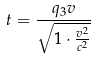<formula> <loc_0><loc_0><loc_500><loc_500>t = \frac { q _ { 3 } v } { \sqrt { 1 \cdot \frac { v ^ { 2 } } { c ^ { 2 } } } }</formula> 